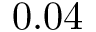Convert formula to latex. <formula><loc_0><loc_0><loc_500><loc_500>0 . 0 4</formula> 